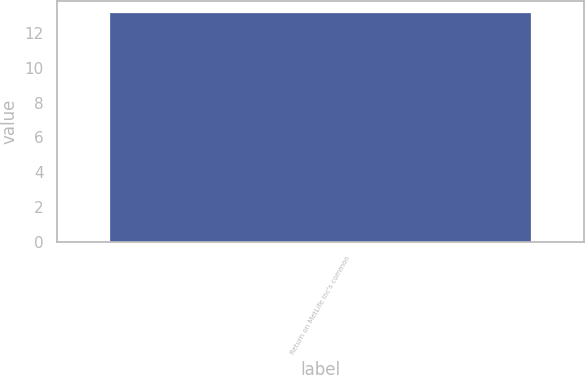Convert chart. <chart><loc_0><loc_0><loc_500><loc_500><bar_chart><fcel>Return on MetLife Inc's common<nl><fcel>13.2<nl></chart> 